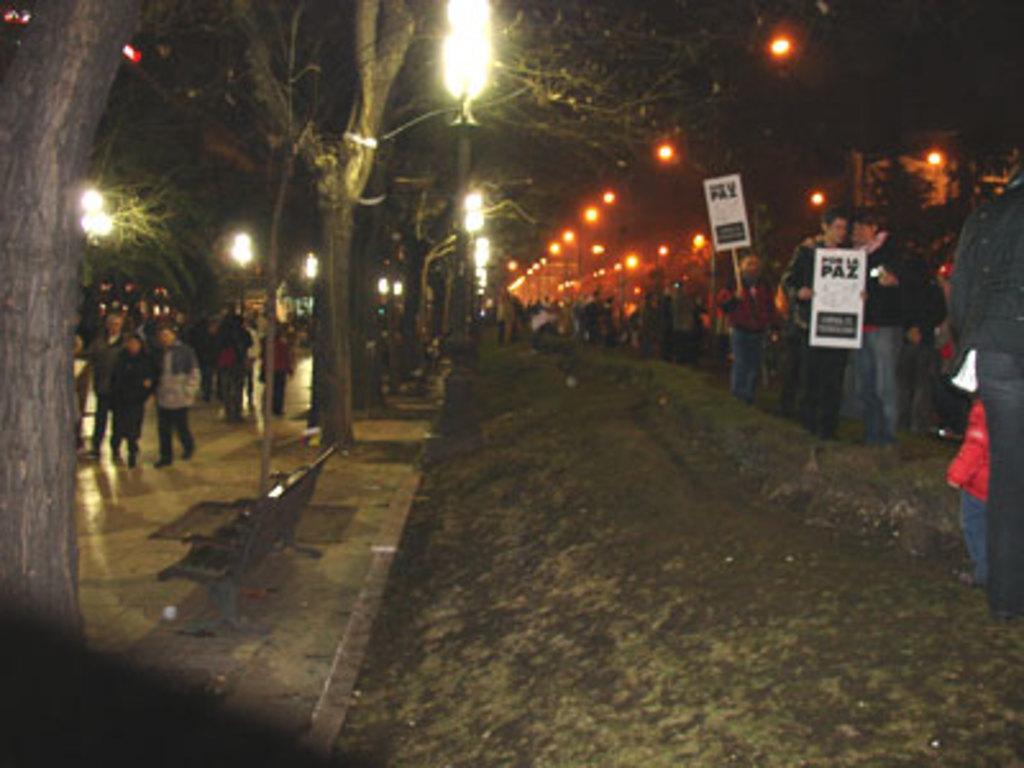Please provide a concise description of this image. In this image we can see a group of people on the ground. In that some are holding the boards with text on them. We can also see a bench, the bark of a tree, some trees, the street poles and the sky. 